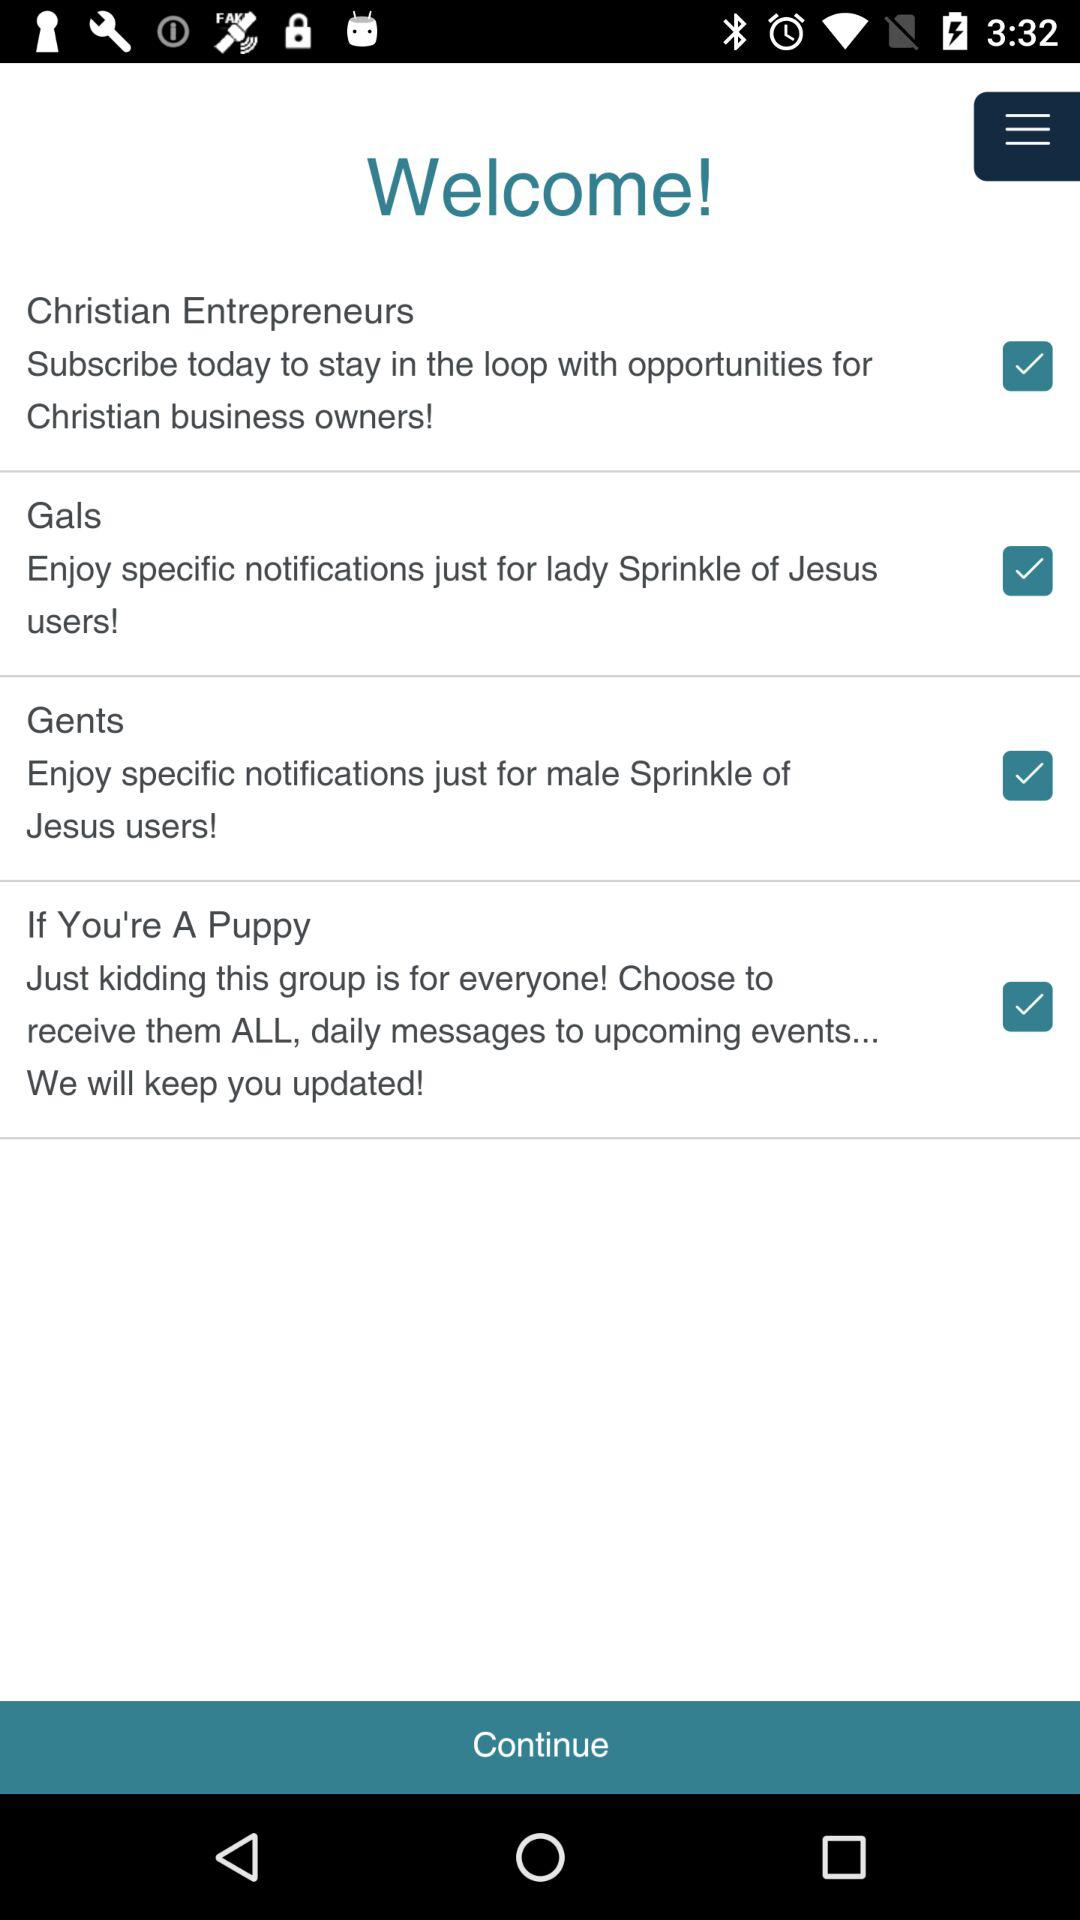How many groups are there?
Answer the question using a single word or phrase. 4 